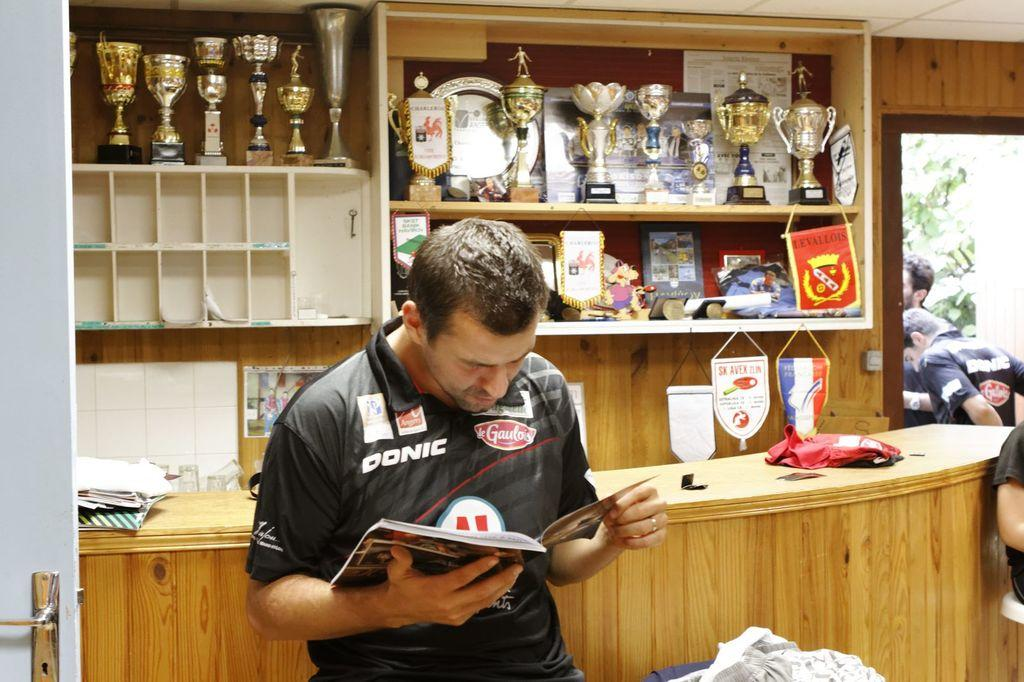<image>
Describe the image concisely. A man in a black Donic jersey looks at a book. 